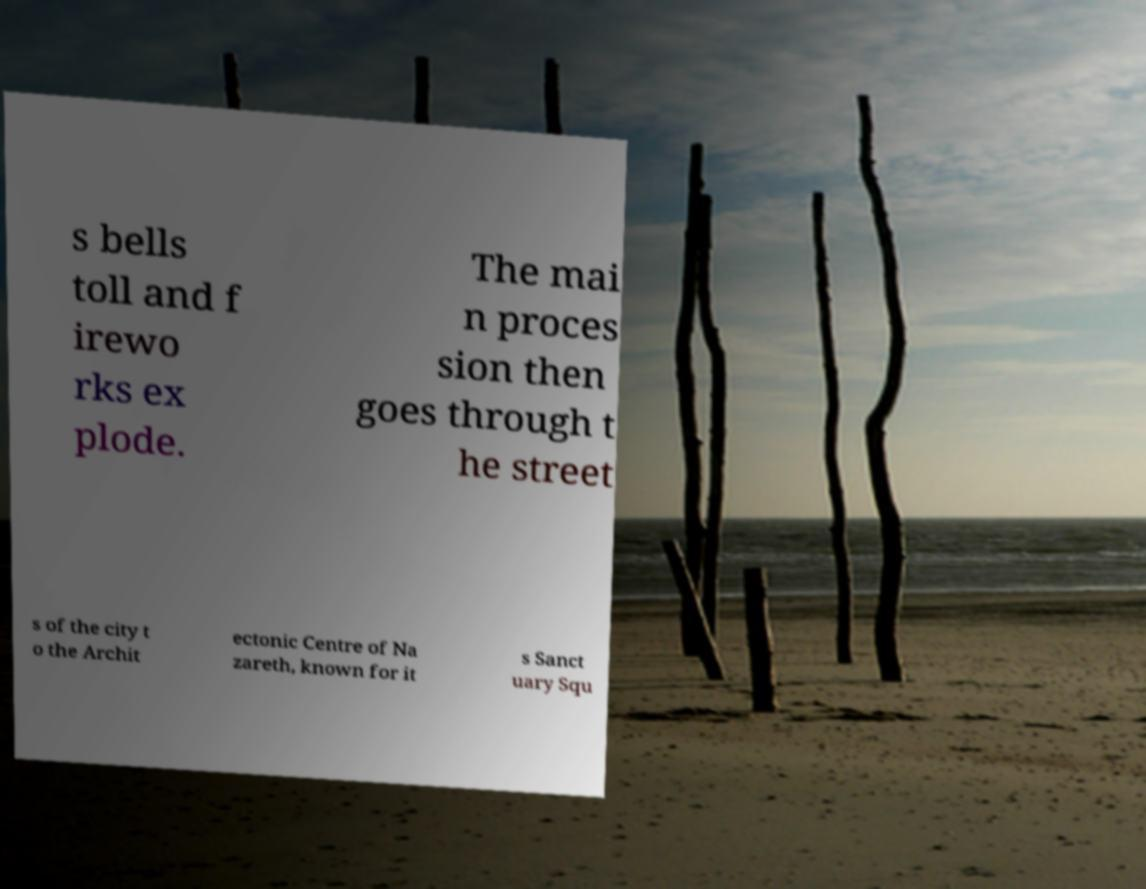Can you accurately transcribe the text from the provided image for me? s bells toll and f irewo rks ex plode. The mai n proces sion then goes through t he street s of the city t o the Archit ectonic Centre of Na zareth, known for it s Sanct uary Squ 